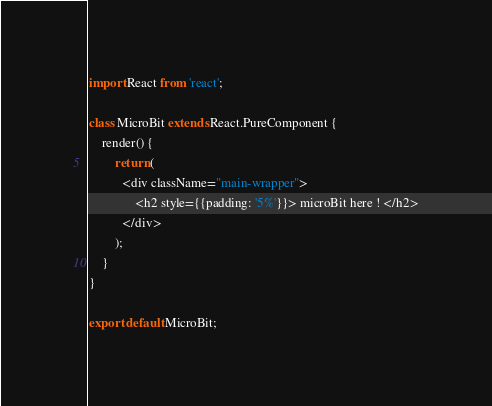Convert code to text. <code><loc_0><loc_0><loc_500><loc_500><_TypeScript_>import React from 'react';

class MicroBit extends React.PureComponent {
    render() {
        return (
          <div className="main-wrapper">
              <h2 style={{padding: '5%'}}> microBit here ! </h2>
          </div>
        );
    }
}

export default MicroBit;
</code> 